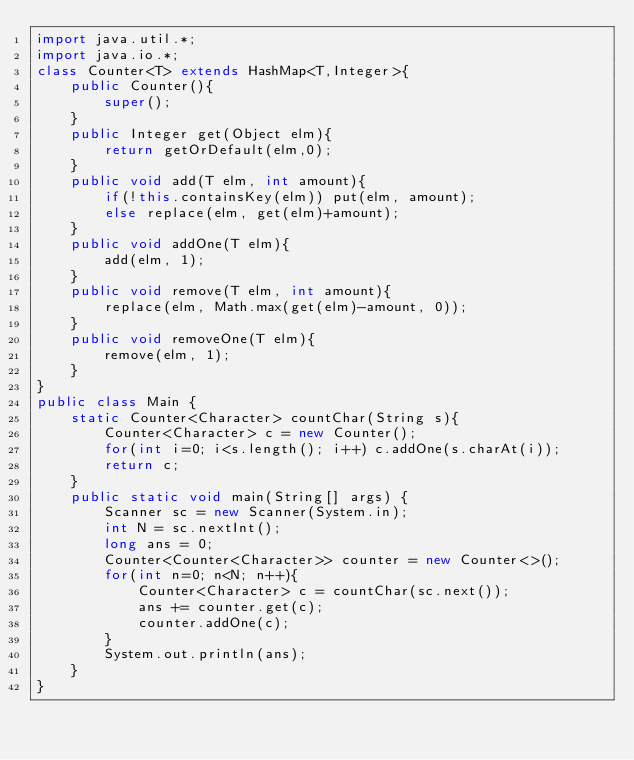<code> <loc_0><loc_0><loc_500><loc_500><_Java_>import java.util.*;
import java.io.*;
class Counter<T> extends HashMap<T,Integer>{
    public Counter(){
        super();
    }
    public Integer get(Object elm){
        return getOrDefault(elm,0);
    }
    public void add(T elm, int amount){
        if(!this.containsKey(elm)) put(elm, amount);
        else replace(elm, get(elm)+amount);
    }
    public void addOne(T elm){
        add(elm, 1);
    }
    public void remove(T elm, int amount){
        replace(elm, Math.max(get(elm)-amount, 0));
    }
    public void removeOne(T elm){
        remove(elm, 1);
    }
}
public class Main {
    static Counter<Character> countChar(String s){
        Counter<Character> c = new Counter();
        for(int i=0; i<s.length(); i++) c.addOne(s.charAt(i));
        return c;
    }
    public static void main(String[] args) {
        Scanner sc = new Scanner(System.in);
        int N = sc.nextInt();
        long ans = 0;
        Counter<Counter<Character>> counter = new Counter<>();
        for(int n=0; n<N; n++){
            Counter<Character> c = countChar(sc.next());
            ans += counter.get(c);
            counter.addOne(c);
        }
        System.out.println(ans);
    }
}</code> 